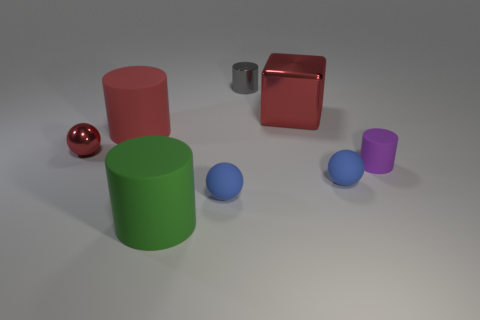Subtract all green balls. Subtract all gray cubes. How many balls are left? 3 Add 1 purple metallic things. How many objects exist? 9 Subtract all blocks. How many objects are left? 7 Add 7 blue balls. How many blue balls exist? 9 Subtract 1 gray cylinders. How many objects are left? 7 Subtract all metallic blocks. Subtract all brown shiny blocks. How many objects are left? 7 Add 1 balls. How many balls are left? 4 